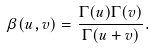<formula> <loc_0><loc_0><loc_500><loc_500>\beta ( u , v ) = \frac { \Gamma ( u ) \Gamma ( v ) } { \Gamma ( u + v ) } .</formula> 